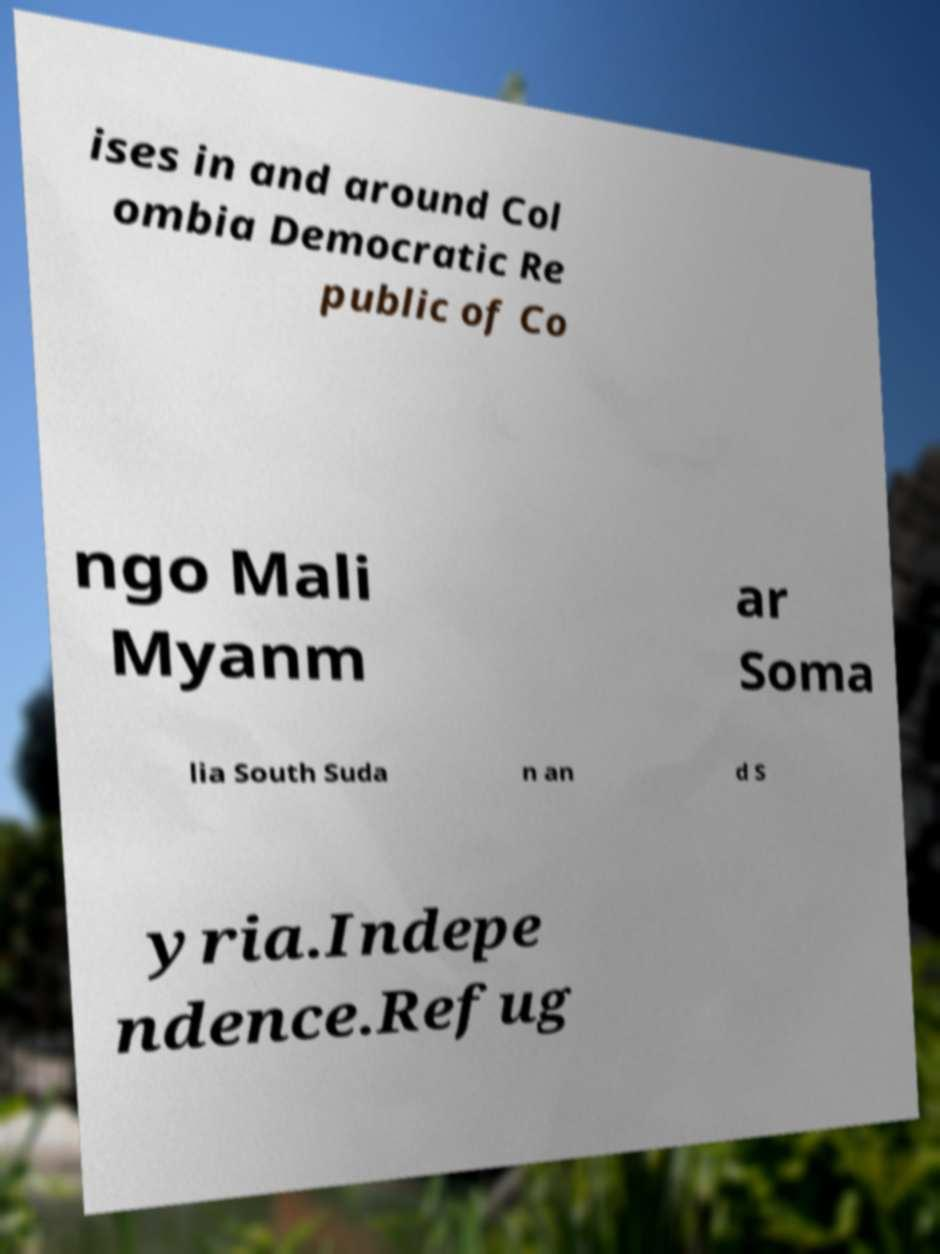For documentation purposes, I need the text within this image transcribed. Could you provide that? ises in and around Col ombia Democratic Re public of Co ngo Mali Myanm ar Soma lia South Suda n an d S yria.Indepe ndence.Refug 